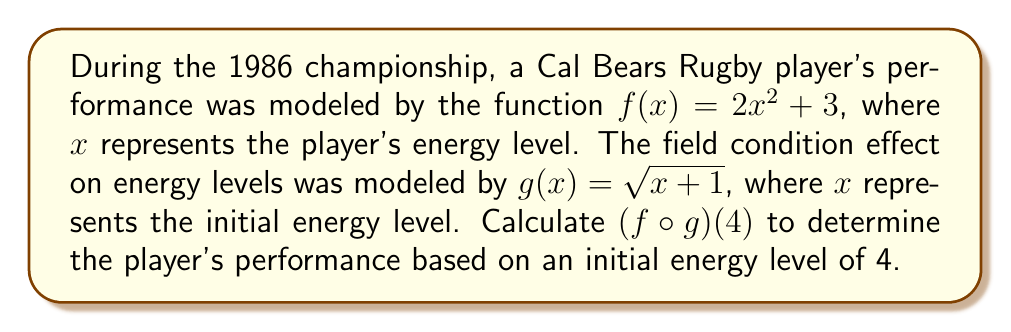Teach me how to tackle this problem. To solve this problem, we need to compute the composition of functions $f \circ g$. This means we first apply function $g$ to the input, then apply function $f$ to the result.

Step 1: Calculate $g(4)$
$g(4) = \sqrt{4+1} = \sqrt{5}$

Step 2: Use the result from Step 1 as input for function $f$
$(f \circ g)(4) = f(g(4)) = f(\sqrt{5})$

Step 3: Calculate $f(\sqrt{5})$
$f(\sqrt{5}) = 2(\sqrt{5})^2 + 3$

Step 4: Simplify the expression
$2(\sqrt{5})^2 + 3 = 2(5) + 3 = 10 + 3 = 13$

Therefore, $(f \circ g)(4) = 13$
Answer: 13 